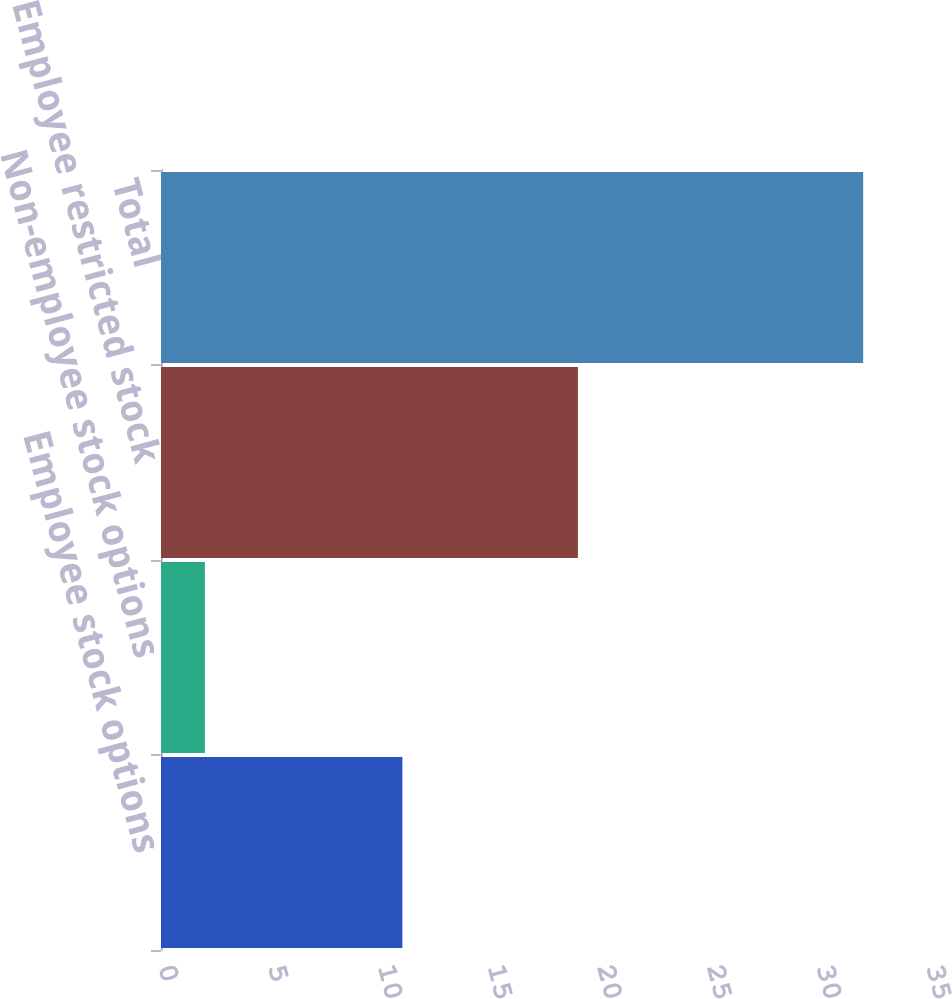Convert chart to OTSL. <chart><loc_0><loc_0><loc_500><loc_500><bar_chart><fcel>Employee stock options<fcel>Non-employee stock options<fcel>Employee restricted stock<fcel>Total<nl><fcel>11<fcel>2<fcel>19<fcel>32<nl></chart> 